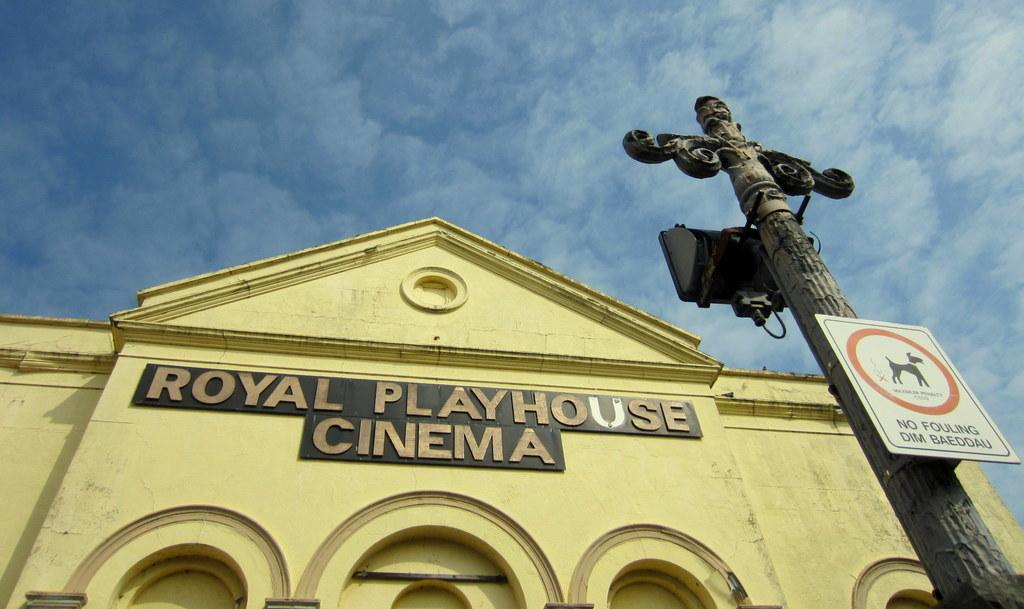<image>
Present a compact description of the photo's key features. the exterior of the yellow building Royal Playhouse Cinema 